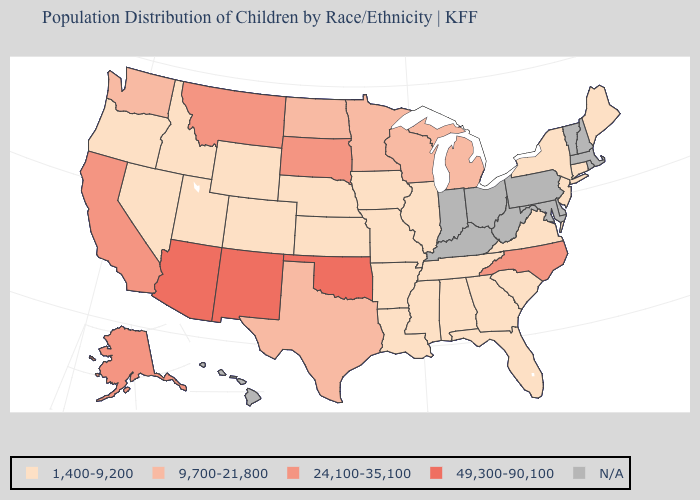Which states have the lowest value in the West?
Short answer required. Colorado, Idaho, Nevada, Oregon, Utah, Wyoming. Among the states that border Colorado , which have the highest value?
Concise answer only. Arizona, New Mexico, Oklahoma. Does the first symbol in the legend represent the smallest category?
Give a very brief answer. Yes. What is the value of New Jersey?
Be succinct. 1,400-9,200. What is the lowest value in the South?
Quick response, please. 1,400-9,200. Name the states that have a value in the range N/A?
Give a very brief answer. Delaware, Hawaii, Indiana, Kentucky, Maryland, Massachusetts, New Hampshire, Ohio, Pennsylvania, Rhode Island, Vermont, West Virginia. What is the value of Wyoming?
Answer briefly. 1,400-9,200. Name the states that have a value in the range 9,700-21,800?
Write a very short answer. Michigan, Minnesota, North Dakota, Texas, Washington, Wisconsin. Name the states that have a value in the range 1,400-9,200?
Keep it brief. Alabama, Arkansas, Colorado, Connecticut, Florida, Georgia, Idaho, Illinois, Iowa, Kansas, Louisiana, Maine, Mississippi, Missouri, Nebraska, Nevada, New Jersey, New York, Oregon, South Carolina, Tennessee, Utah, Virginia, Wyoming. What is the value of Nebraska?
Keep it brief. 1,400-9,200. What is the value of Vermont?
Concise answer only. N/A. Does the map have missing data?
Write a very short answer. Yes. Does Mississippi have the highest value in the USA?
Write a very short answer. No. Name the states that have a value in the range 49,300-90,100?
Answer briefly. Arizona, New Mexico, Oklahoma. Is the legend a continuous bar?
Give a very brief answer. No. 